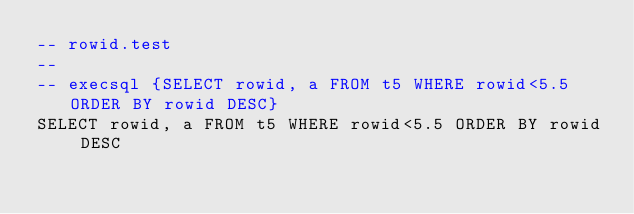Convert code to text. <code><loc_0><loc_0><loc_500><loc_500><_SQL_>-- rowid.test
-- 
-- execsql {SELECT rowid, a FROM t5 WHERE rowid<5.5 ORDER BY rowid DESC}
SELECT rowid, a FROM t5 WHERE rowid<5.5 ORDER BY rowid DESC</code> 